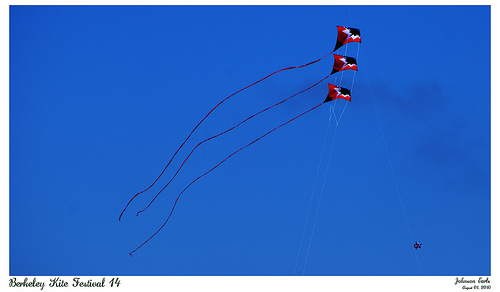<image>
Is there a kite behind the kite? No. The kite is not behind the kite. From this viewpoint, the kite appears to be positioned elsewhere in the scene. 